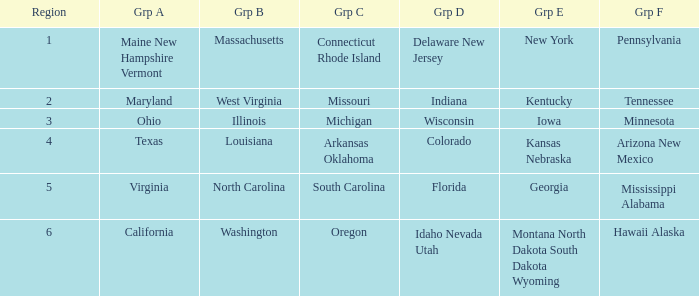When considering illinois as a part of group b, which region is classified as group c? Michigan. 